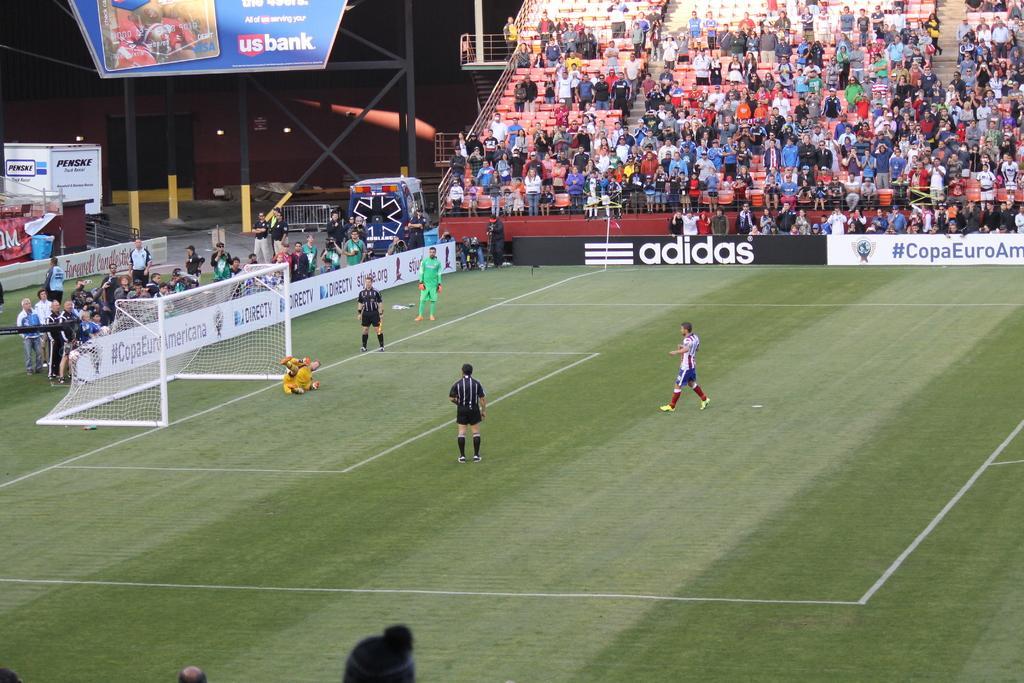Please provide a concise description of this image. In this image we can see a playground and players are playing game. Left side of the image people are standing and taking photographs. Top of the image sitting area of the stadium is there and crowd is present. 